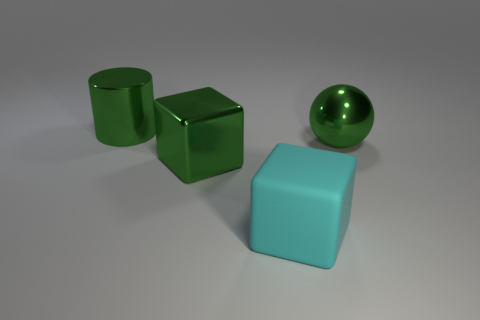Are there any big brown cubes made of the same material as the big green cylinder?
Offer a terse response. No. Are there more large metal cylinders left of the green cylinder than large cyan blocks that are behind the cyan object?
Your answer should be very brief. No. Is the metallic cylinder the same size as the shiny cube?
Ensure brevity in your answer.  Yes. There is a large thing that is behind the sphere right of the cyan matte block; what color is it?
Provide a succinct answer. Green. The large matte cube is what color?
Make the answer very short. Cyan. Is there a big ball of the same color as the rubber thing?
Ensure brevity in your answer.  No. There is a large metal thing that is behind the green shiny sphere; is it the same color as the rubber object?
Give a very brief answer. No. How many things are either objects that are left of the large green sphere or large matte things?
Provide a succinct answer. 3. Are there any big green shiny cubes on the right side of the matte object?
Your answer should be very brief. No. There is a block that is the same color as the large shiny sphere; what is its material?
Your answer should be compact. Metal. 